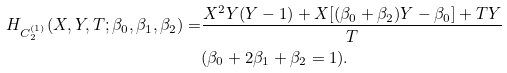Convert formula to latex. <formula><loc_0><loc_0><loc_500><loc_500>H _ { C _ { 2 } ^ { ( 1 ) } } ( X , Y , T ; \beta _ { 0 } , \beta _ { 1 } , \beta _ { 2 } ) = & \frac { X ^ { 2 } Y ( Y - 1 ) + X [ ( \beta _ { 0 } + \beta _ { 2 } ) Y - \beta _ { 0 } ] + T Y } { T } \\ & ( \beta _ { 0 } + 2 \beta _ { 1 } + \beta _ { 2 } = 1 ) .</formula> 